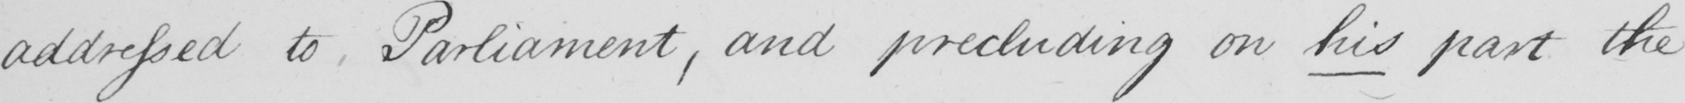Can you tell me what this handwritten text says? addressed to Parliament , and precluding on his part the 